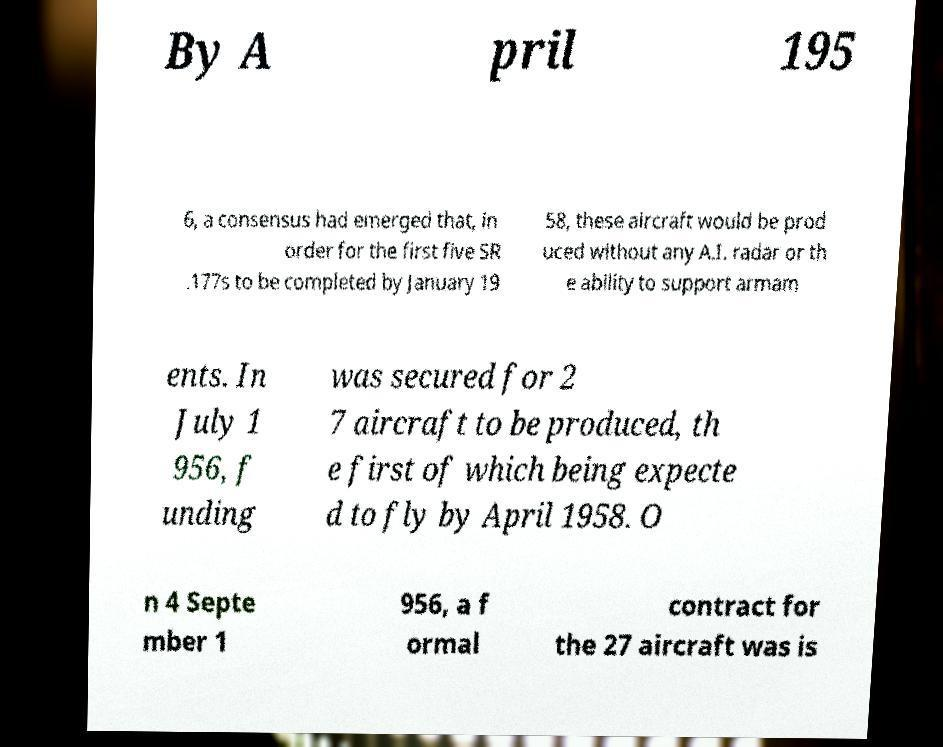Please identify and transcribe the text found in this image. By A pril 195 6, a consensus had emerged that, in order for the first five SR .177s to be completed by January 19 58, these aircraft would be prod uced without any A.I. radar or th e ability to support armam ents. In July 1 956, f unding was secured for 2 7 aircraft to be produced, th e first of which being expecte d to fly by April 1958. O n 4 Septe mber 1 956, a f ormal contract for the 27 aircraft was is 